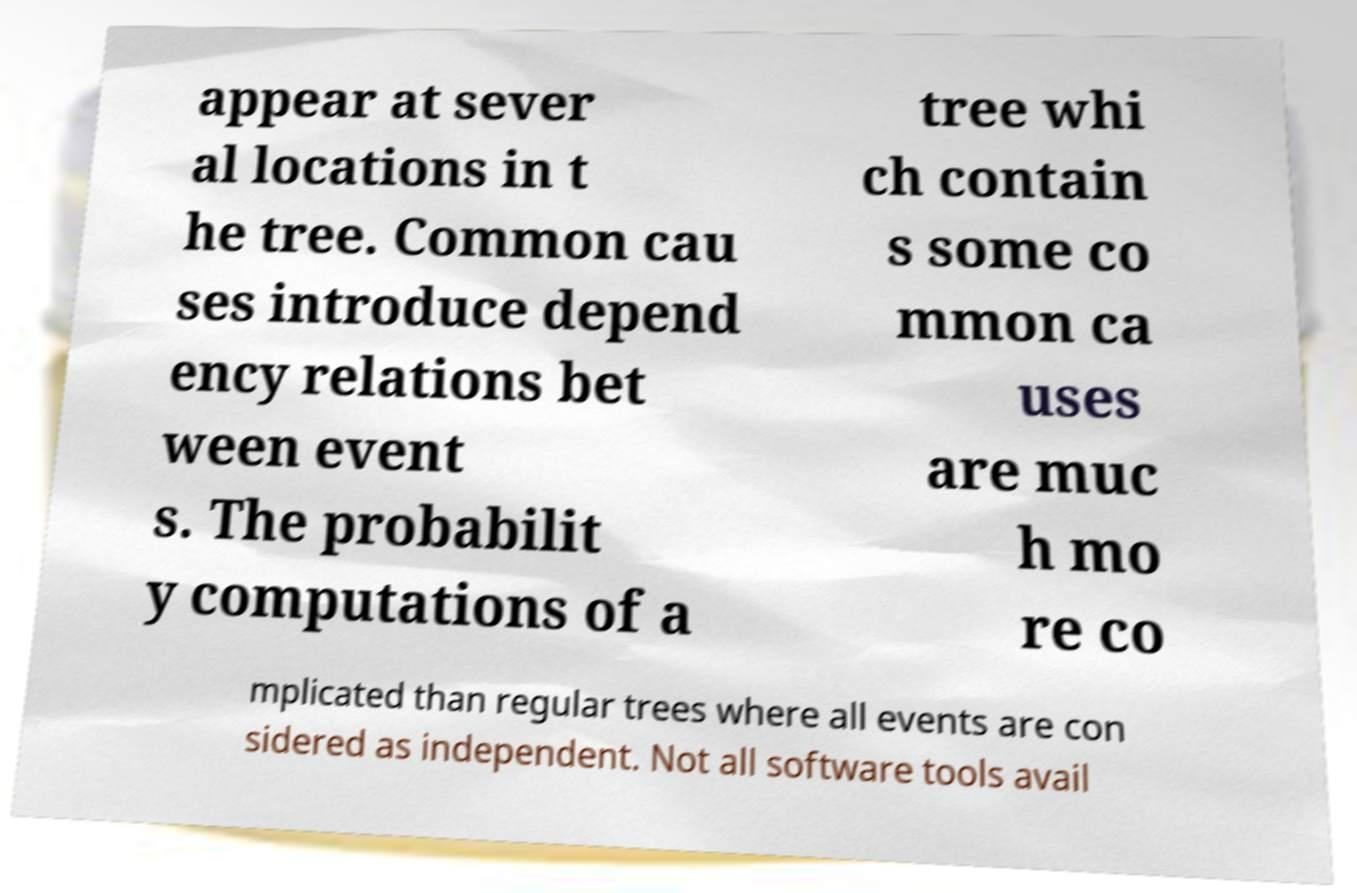For documentation purposes, I need the text within this image transcribed. Could you provide that? appear at sever al locations in t he tree. Common cau ses introduce depend ency relations bet ween event s. The probabilit y computations of a tree whi ch contain s some co mmon ca uses are muc h mo re co mplicated than regular trees where all events are con sidered as independent. Not all software tools avail 